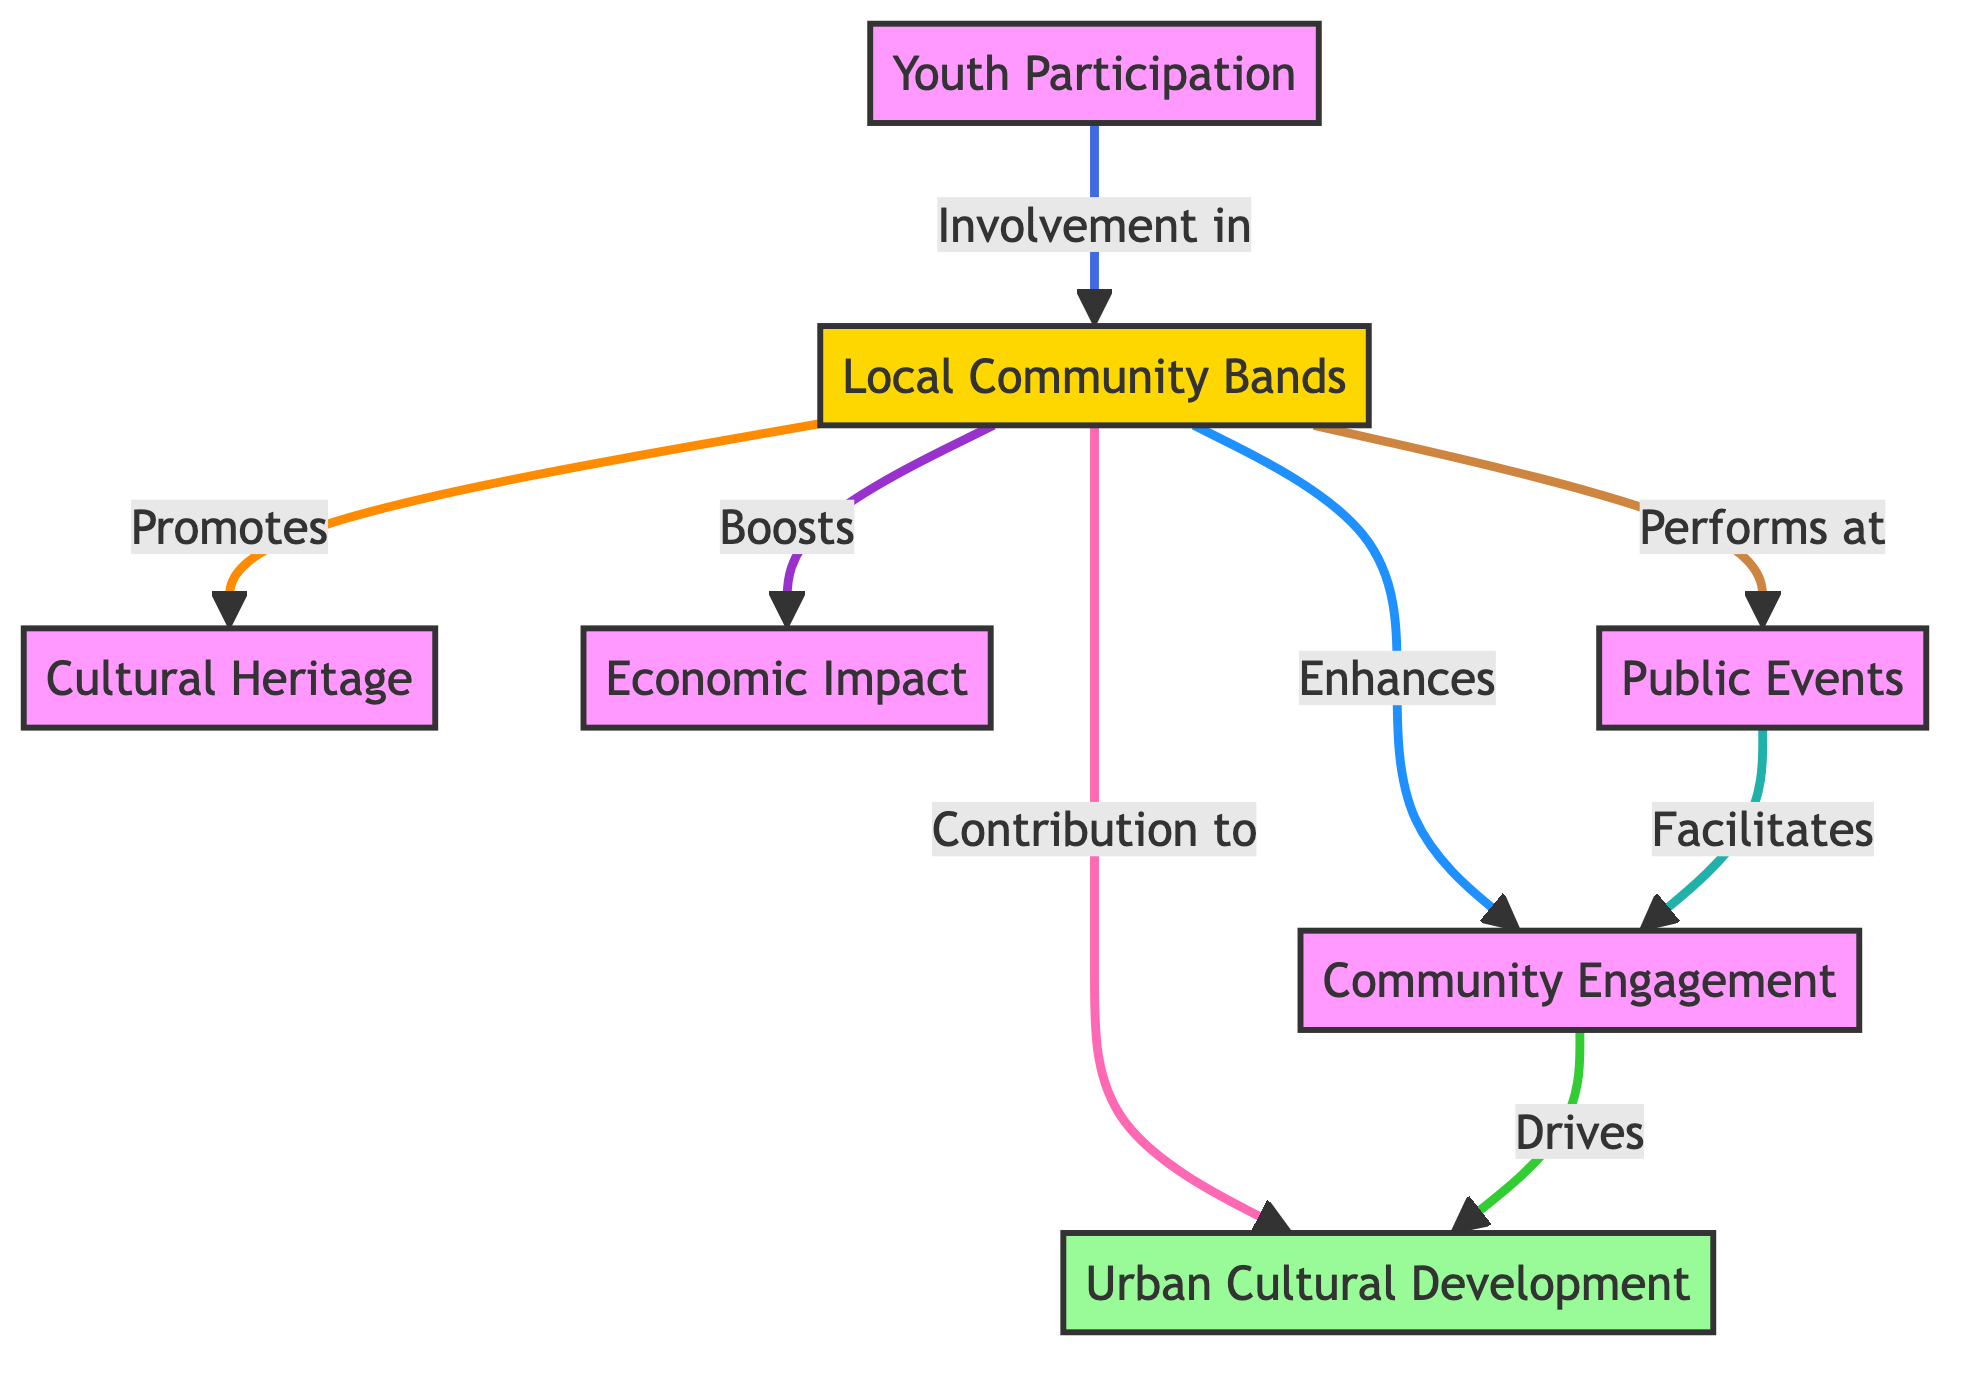What is the primary node representing the local community's contribution? The diagram shows "Local Community Bands" as the primary node connecting to various aspects of urban culture. It is the source of contributions leading to urban cultural development.
Answer: Local Community Bands How many nodes are directly connected to "Local Community Bands"? Counting the arrows leading from "Local Community Bands", we see there are six different nodes it connects to, indicating various impacts and contributions made by the bands.
Answer: 6 What does "Local Community Bands" promote? The direct connection from "Local Community Bands" to "Cultural Heritage" in the diagram indicates that it promotes cultural heritage within urban settings.
Answer: Cultural Heritage Which node is directly connected to both "Community Engagement" and "Urban Cultural Development"? Following the arrows, "Community Engagement" drives "Urban Cultural Development", making it clear that it has a direct impact on this aspect as outlined by the diagram.
Answer: Community Engagement What is the result of "Local Community Bands" boosting? The flow in the diagram shows a clear line from "Local Community Bands" to "Economic Impact", which means that their activities boost the local economy in urban areas.
Answer: Economic Impact How are public events facilitated according to the diagram? The diagram indicates that "Public Events" facilitate "Community Engagement," suggesting that events organized by bands encourage more community involvement and participation.
Answer: Community Engagement What role do youth play according to the diagram? The arrow leading from "Youth Participation" to "Local Community Bands" signifies that involvement in local bands is an activity where youth can participate, showcasing their role within the community music scene.
Answer: Involvement in Local Community Bands Which color represents the "Local Community Bands" node? The diagram visually uses yellow for "Local Community Bands," distinguishing it from other nodes contributing to urban cultural development.
Answer: Yellow What type of events do community bands perform at? Often, community bands are seen performing at "Public Events," a direct correlation shown in the diagram that emphasizes their role in community celebrations.
Answer: Public Events 